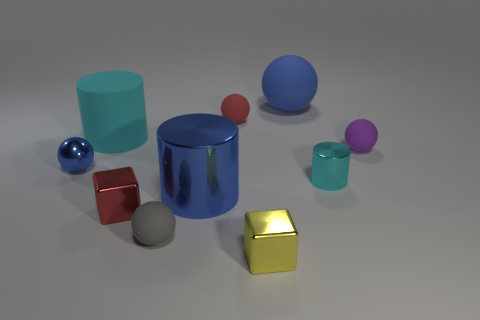Subtract all matte cylinders. How many cylinders are left? 2 Subtract all blue spheres. How many spheres are left? 3 Subtract 1 cylinders. How many cylinders are left? 2 Subtract all cubes. How many objects are left? 8 Subtract all green balls. Subtract all cyan cylinders. How many balls are left? 5 Add 7 gray rubber objects. How many gray rubber objects exist? 8 Subtract 1 gray spheres. How many objects are left? 9 Subtract all yellow cubes. Subtract all balls. How many objects are left? 4 Add 4 yellow shiny objects. How many yellow shiny objects are left? 5 